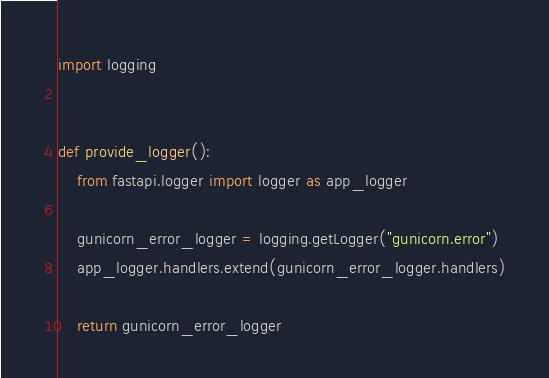Convert code to text. <code><loc_0><loc_0><loc_500><loc_500><_Python_>import logging


def provide_logger():
    from fastapi.logger import logger as app_logger

    gunicorn_error_logger = logging.getLogger("gunicorn.error")
    app_logger.handlers.extend(gunicorn_error_logger.handlers)

    return gunicorn_error_logger
</code> 